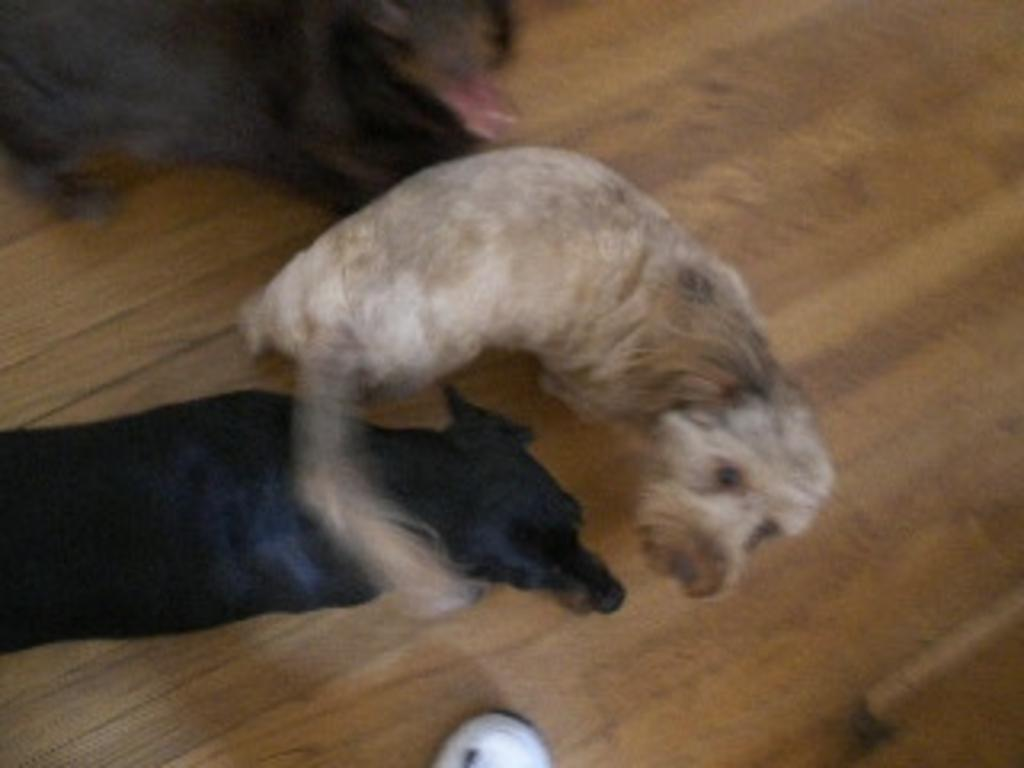What type of animals are present in the image? There are dogs in the image. What surface are the dogs on? The dogs are on a wooden surface. How many giraffes can be seen in the image? There are no giraffes present in the image; it features dogs on a wooden surface. What type of cloud is visible in the image? There is no cloud visible in the image, as it only features dogs on a wooden surface. 